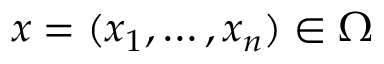<formula> <loc_0><loc_0><loc_500><loc_500>x = ( x _ { 1 } , \dots , x _ { n } ) \in \Omega</formula> 